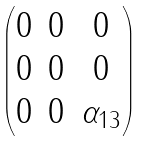<formula> <loc_0><loc_0><loc_500><loc_500>\begin{pmatrix} 0 & 0 & 0 \\ 0 & 0 & 0 \\ 0 & 0 & \alpha _ { 1 3 } \\ \end{pmatrix}</formula> 